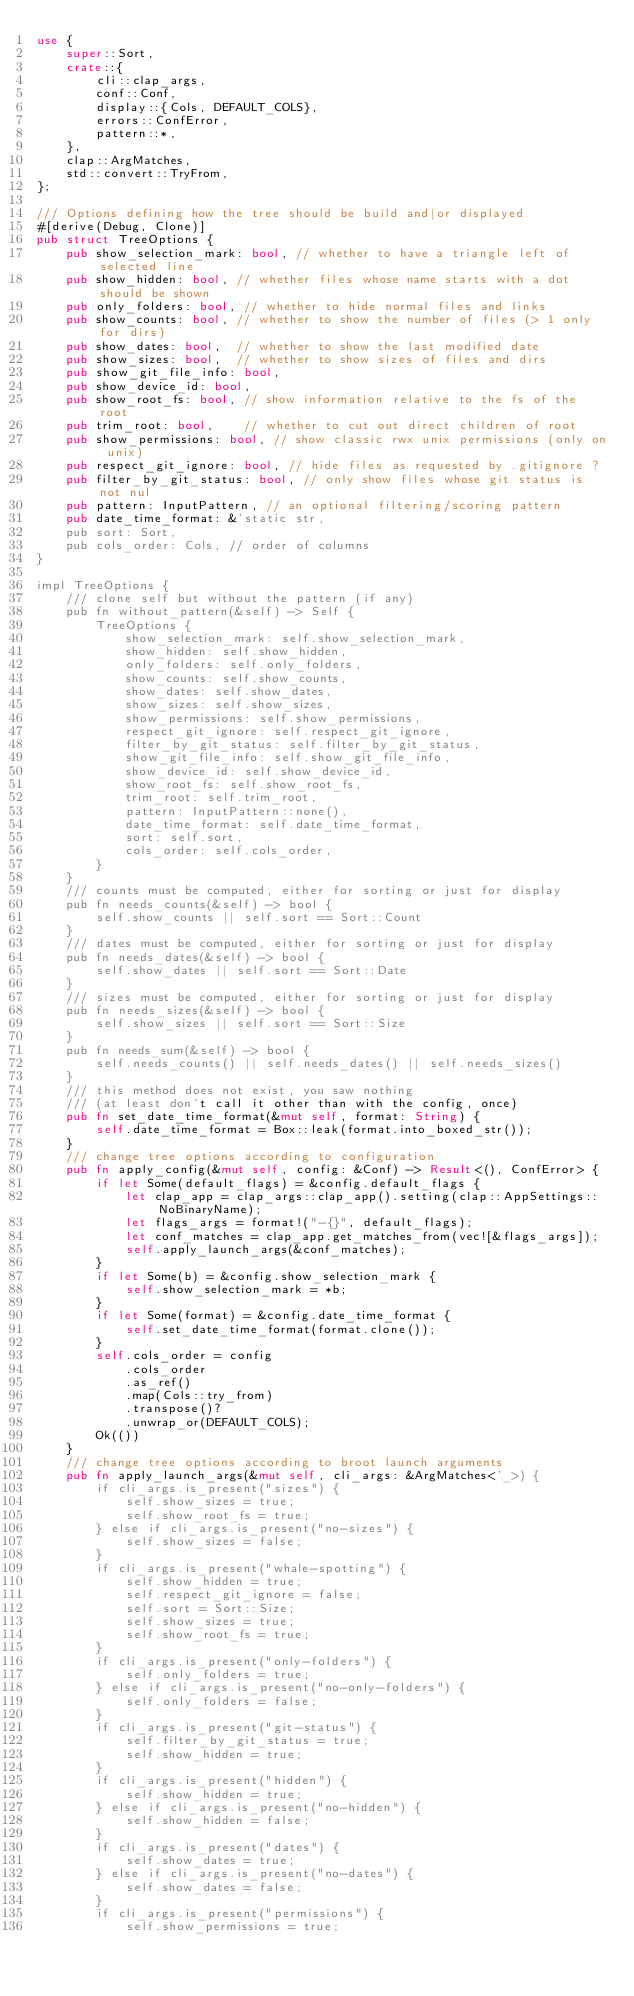<code> <loc_0><loc_0><loc_500><loc_500><_Rust_>use {
    super::Sort,
    crate::{
        cli::clap_args,
        conf::Conf,
        display::{Cols, DEFAULT_COLS},
        errors::ConfError,
        pattern::*,
    },
    clap::ArgMatches,
    std::convert::TryFrom,
};

/// Options defining how the tree should be build and|or displayed
#[derive(Debug, Clone)]
pub struct TreeOptions {
    pub show_selection_mark: bool, // whether to have a triangle left of selected line
    pub show_hidden: bool, // whether files whose name starts with a dot should be shown
    pub only_folders: bool, // whether to hide normal files and links
    pub show_counts: bool, // whether to show the number of files (> 1 only for dirs)
    pub show_dates: bool,  // whether to show the last modified date
    pub show_sizes: bool,  // whether to show sizes of files and dirs
    pub show_git_file_info: bool,
    pub show_device_id: bool,
    pub show_root_fs: bool, // show information relative to the fs of the root
    pub trim_root: bool,    // whether to cut out direct children of root
    pub show_permissions: bool, // show classic rwx unix permissions (only on unix)
    pub respect_git_ignore: bool, // hide files as requested by .gitignore ?
    pub filter_by_git_status: bool, // only show files whose git status is not nul
    pub pattern: InputPattern, // an optional filtering/scoring pattern
    pub date_time_format: &'static str,
    pub sort: Sort,
    pub cols_order: Cols, // order of columns
}

impl TreeOptions {
    /// clone self but without the pattern (if any)
    pub fn without_pattern(&self) -> Self {
        TreeOptions {
            show_selection_mark: self.show_selection_mark,
            show_hidden: self.show_hidden,
            only_folders: self.only_folders,
            show_counts: self.show_counts,
            show_dates: self.show_dates,
            show_sizes: self.show_sizes,
            show_permissions: self.show_permissions,
            respect_git_ignore: self.respect_git_ignore,
            filter_by_git_status: self.filter_by_git_status,
            show_git_file_info: self.show_git_file_info,
            show_device_id: self.show_device_id,
            show_root_fs: self.show_root_fs,
            trim_root: self.trim_root,
            pattern: InputPattern::none(),
            date_time_format: self.date_time_format,
            sort: self.sort,
            cols_order: self.cols_order,
        }
    }
    /// counts must be computed, either for sorting or just for display
    pub fn needs_counts(&self) -> bool {
        self.show_counts || self.sort == Sort::Count
    }
    /// dates must be computed, either for sorting or just for display
    pub fn needs_dates(&self) -> bool {
        self.show_dates || self.sort == Sort::Date
    }
    /// sizes must be computed, either for sorting or just for display
    pub fn needs_sizes(&self) -> bool {
        self.show_sizes || self.sort == Sort::Size
    }
    pub fn needs_sum(&self) -> bool {
        self.needs_counts() || self.needs_dates() || self.needs_sizes()
    }
    /// this method does not exist, you saw nothing
    /// (at least don't call it other than with the config, once)
    pub fn set_date_time_format(&mut self, format: String) {
        self.date_time_format = Box::leak(format.into_boxed_str());
    }
    /// change tree options according to configuration
    pub fn apply_config(&mut self, config: &Conf) -> Result<(), ConfError> {
        if let Some(default_flags) = &config.default_flags {
            let clap_app = clap_args::clap_app().setting(clap::AppSettings::NoBinaryName);
            let flags_args = format!("-{}", default_flags);
            let conf_matches = clap_app.get_matches_from(vec![&flags_args]);
            self.apply_launch_args(&conf_matches);
        }
        if let Some(b) = &config.show_selection_mark {
            self.show_selection_mark = *b;
        }
        if let Some(format) = &config.date_time_format {
            self.set_date_time_format(format.clone());
        }
        self.cols_order = config
            .cols_order
            .as_ref()
            .map(Cols::try_from)
            .transpose()?
            .unwrap_or(DEFAULT_COLS);
        Ok(())
    }
    /// change tree options according to broot launch arguments
    pub fn apply_launch_args(&mut self, cli_args: &ArgMatches<'_>) {
        if cli_args.is_present("sizes") {
            self.show_sizes = true;
            self.show_root_fs = true;
        } else if cli_args.is_present("no-sizes") {
            self.show_sizes = false;
        }
        if cli_args.is_present("whale-spotting") {
            self.show_hidden = true;
            self.respect_git_ignore = false;
            self.sort = Sort::Size;
            self.show_sizes = true;
            self.show_root_fs = true;
        }
        if cli_args.is_present("only-folders") {
            self.only_folders = true;
        } else if cli_args.is_present("no-only-folders") {
            self.only_folders = false;
        }
        if cli_args.is_present("git-status") {
            self.filter_by_git_status = true;
            self.show_hidden = true;
        }
        if cli_args.is_present("hidden") {
            self.show_hidden = true;
        } else if cli_args.is_present("no-hidden") {
            self.show_hidden = false;
        }
        if cli_args.is_present("dates") {
            self.show_dates = true;
        } else if cli_args.is_present("no-dates") {
            self.show_dates = false;
        }
        if cli_args.is_present("permissions") {
            self.show_permissions = true;</code> 